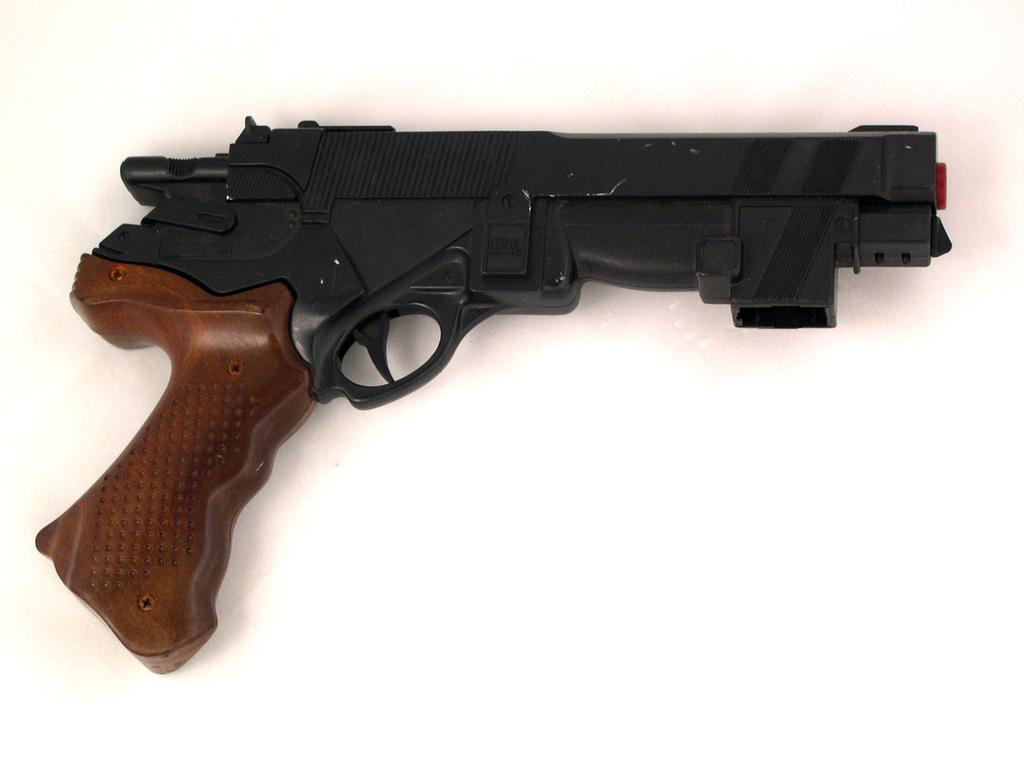What object is the main focus of the image? There is a gun in the image. Can you describe the appearance of the gun? The gun is brown and black in color. How many lizards are sitting on the gun in the image? There are no lizards present in the image; it only features a gun. What type of smile can be seen on the gun in the image? Guns do not have the ability to smile, so this question is not applicable to the image. 